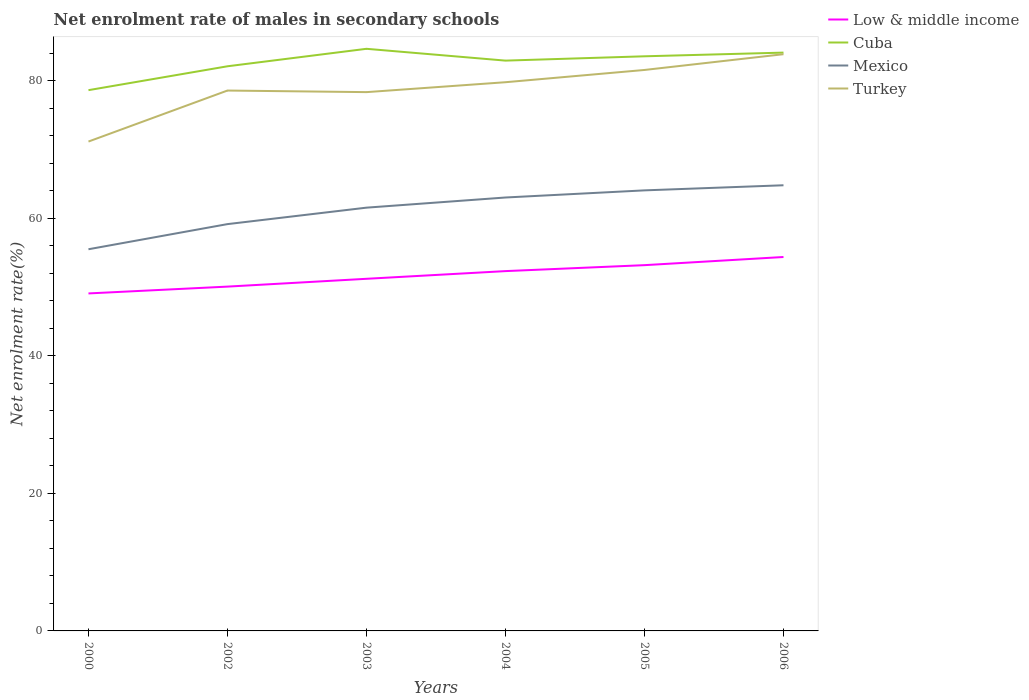How many different coloured lines are there?
Provide a succinct answer. 4. Across all years, what is the maximum net enrolment rate of males in secondary schools in Cuba?
Offer a terse response. 78.62. What is the total net enrolment rate of males in secondary schools in Cuba in the graph?
Keep it short and to the point. -4.29. What is the difference between the highest and the second highest net enrolment rate of males in secondary schools in Low & middle income?
Provide a succinct answer. 5.3. Is the net enrolment rate of males in secondary schools in Turkey strictly greater than the net enrolment rate of males in secondary schools in Mexico over the years?
Offer a very short reply. No. How many lines are there?
Ensure brevity in your answer.  4. What is the difference between two consecutive major ticks on the Y-axis?
Keep it short and to the point. 20. Are the values on the major ticks of Y-axis written in scientific E-notation?
Your response must be concise. No. How are the legend labels stacked?
Your response must be concise. Vertical. What is the title of the graph?
Make the answer very short. Net enrolment rate of males in secondary schools. Does "Timor-Leste" appear as one of the legend labels in the graph?
Make the answer very short. No. What is the label or title of the Y-axis?
Your response must be concise. Net enrolment rate(%). What is the Net enrolment rate(%) of Low & middle income in 2000?
Provide a succinct answer. 49.07. What is the Net enrolment rate(%) in Cuba in 2000?
Provide a short and direct response. 78.62. What is the Net enrolment rate(%) of Mexico in 2000?
Offer a very short reply. 55.49. What is the Net enrolment rate(%) of Turkey in 2000?
Provide a short and direct response. 71.15. What is the Net enrolment rate(%) of Low & middle income in 2002?
Provide a succinct answer. 50.06. What is the Net enrolment rate(%) of Cuba in 2002?
Your answer should be very brief. 82.09. What is the Net enrolment rate(%) in Mexico in 2002?
Provide a succinct answer. 59.15. What is the Net enrolment rate(%) in Turkey in 2002?
Offer a terse response. 78.57. What is the Net enrolment rate(%) in Low & middle income in 2003?
Provide a short and direct response. 51.2. What is the Net enrolment rate(%) in Cuba in 2003?
Give a very brief answer. 84.63. What is the Net enrolment rate(%) of Mexico in 2003?
Ensure brevity in your answer.  61.54. What is the Net enrolment rate(%) in Turkey in 2003?
Provide a short and direct response. 78.34. What is the Net enrolment rate(%) of Low & middle income in 2004?
Ensure brevity in your answer.  52.31. What is the Net enrolment rate(%) of Cuba in 2004?
Make the answer very short. 82.92. What is the Net enrolment rate(%) in Mexico in 2004?
Your response must be concise. 63.02. What is the Net enrolment rate(%) of Turkey in 2004?
Provide a short and direct response. 79.78. What is the Net enrolment rate(%) in Low & middle income in 2005?
Your answer should be very brief. 53.18. What is the Net enrolment rate(%) of Cuba in 2005?
Your answer should be very brief. 83.54. What is the Net enrolment rate(%) of Mexico in 2005?
Offer a very short reply. 64.05. What is the Net enrolment rate(%) of Turkey in 2005?
Ensure brevity in your answer.  81.56. What is the Net enrolment rate(%) in Low & middle income in 2006?
Provide a succinct answer. 54.36. What is the Net enrolment rate(%) of Cuba in 2006?
Offer a terse response. 84.08. What is the Net enrolment rate(%) of Mexico in 2006?
Keep it short and to the point. 64.79. What is the Net enrolment rate(%) of Turkey in 2006?
Provide a short and direct response. 83.85. Across all years, what is the maximum Net enrolment rate(%) of Low & middle income?
Ensure brevity in your answer.  54.36. Across all years, what is the maximum Net enrolment rate(%) in Cuba?
Keep it short and to the point. 84.63. Across all years, what is the maximum Net enrolment rate(%) of Mexico?
Your answer should be compact. 64.79. Across all years, what is the maximum Net enrolment rate(%) of Turkey?
Give a very brief answer. 83.85. Across all years, what is the minimum Net enrolment rate(%) in Low & middle income?
Offer a very short reply. 49.07. Across all years, what is the minimum Net enrolment rate(%) in Cuba?
Make the answer very short. 78.62. Across all years, what is the minimum Net enrolment rate(%) of Mexico?
Offer a very short reply. 55.49. Across all years, what is the minimum Net enrolment rate(%) in Turkey?
Give a very brief answer. 71.15. What is the total Net enrolment rate(%) of Low & middle income in the graph?
Give a very brief answer. 310.18. What is the total Net enrolment rate(%) in Cuba in the graph?
Give a very brief answer. 495.9. What is the total Net enrolment rate(%) of Mexico in the graph?
Your answer should be compact. 368.04. What is the total Net enrolment rate(%) in Turkey in the graph?
Provide a succinct answer. 473.24. What is the difference between the Net enrolment rate(%) in Low & middle income in 2000 and that in 2002?
Provide a succinct answer. -0.99. What is the difference between the Net enrolment rate(%) of Cuba in 2000 and that in 2002?
Ensure brevity in your answer.  -3.47. What is the difference between the Net enrolment rate(%) of Mexico in 2000 and that in 2002?
Provide a short and direct response. -3.65. What is the difference between the Net enrolment rate(%) in Turkey in 2000 and that in 2002?
Provide a short and direct response. -7.42. What is the difference between the Net enrolment rate(%) in Low & middle income in 2000 and that in 2003?
Your answer should be compact. -2.13. What is the difference between the Net enrolment rate(%) in Cuba in 2000 and that in 2003?
Keep it short and to the point. -6.01. What is the difference between the Net enrolment rate(%) of Mexico in 2000 and that in 2003?
Offer a very short reply. -6.05. What is the difference between the Net enrolment rate(%) of Turkey in 2000 and that in 2003?
Keep it short and to the point. -7.19. What is the difference between the Net enrolment rate(%) in Low & middle income in 2000 and that in 2004?
Provide a short and direct response. -3.25. What is the difference between the Net enrolment rate(%) of Cuba in 2000 and that in 2004?
Offer a terse response. -4.29. What is the difference between the Net enrolment rate(%) of Mexico in 2000 and that in 2004?
Your response must be concise. -7.52. What is the difference between the Net enrolment rate(%) in Turkey in 2000 and that in 2004?
Offer a very short reply. -8.63. What is the difference between the Net enrolment rate(%) in Low & middle income in 2000 and that in 2005?
Give a very brief answer. -4.11. What is the difference between the Net enrolment rate(%) in Cuba in 2000 and that in 2005?
Make the answer very short. -4.92. What is the difference between the Net enrolment rate(%) in Mexico in 2000 and that in 2005?
Provide a short and direct response. -8.56. What is the difference between the Net enrolment rate(%) in Turkey in 2000 and that in 2005?
Your answer should be very brief. -10.41. What is the difference between the Net enrolment rate(%) in Low & middle income in 2000 and that in 2006?
Give a very brief answer. -5.3. What is the difference between the Net enrolment rate(%) in Cuba in 2000 and that in 2006?
Offer a terse response. -5.46. What is the difference between the Net enrolment rate(%) of Mexico in 2000 and that in 2006?
Keep it short and to the point. -9.3. What is the difference between the Net enrolment rate(%) of Turkey in 2000 and that in 2006?
Give a very brief answer. -12.7. What is the difference between the Net enrolment rate(%) in Low & middle income in 2002 and that in 2003?
Offer a terse response. -1.14. What is the difference between the Net enrolment rate(%) in Cuba in 2002 and that in 2003?
Offer a very short reply. -2.54. What is the difference between the Net enrolment rate(%) of Mexico in 2002 and that in 2003?
Your answer should be very brief. -2.39. What is the difference between the Net enrolment rate(%) of Turkey in 2002 and that in 2003?
Offer a very short reply. 0.23. What is the difference between the Net enrolment rate(%) of Low & middle income in 2002 and that in 2004?
Make the answer very short. -2.25. What is the difference between the Net enrolment rate(%) of Cuba in 2002 and that in 2004?
Your answer should be very brief. -0.82. What is the difference between the Net enrolment rate(%) in Mexico in 2002 and that in 2004?
Your response must be concise. -3.87. What is the difference between the Net enrolment rate(%) of Turkey in 2002 and that in 2004?
Make the answer very short. -1.21. What is the difference between the Net enrolment rate(%) in Low & middle income in 2002 and that in 2005?
Provide a short and direct response. -3.12. What is the difference between the Net enrolment rate(%) of Cuba in 2002 and that in 2005?
Provide a short and direct response. -1.45. What is the difference between the Net enrolment rate(%) in Mexico in 2002 and that in 2005?
Ensure brevity in your answer.  -4.91. What is the difference between the Net enrolment rate(%) in Turkey in 2002 and that in 2005?
Your response must be concise. -2.99. What is the difference between the Net enrolment rate(%) of Low & middle income in 2002 and that in 2006?
Your response must be concise. -4.3. What is the difference between the Net enrolment rate(%) of Cuba in 2002 and that in 2006?
Your answer should be compact. -1.99. What is the difference between the Net enrolment rate(%) in Mexico in 2002 and that in 2006?
Offer a very short reply. -5.65. What is the difference between the Net enrolment rate(%) in Turkey in 2002 and that in 2006?
Your response must be concise. -5.28. What is the difference between the Net enrolment rate(%) of Low & middle income in 2003 and that in 2004?
Your answer should be compact. -1.12. What is the difference between the Net enrolment rate(%) of Cuba in 2003 and that in 2004?
Your answer should be compact. 1.72. What is the difference between the Net enrolment rate(%) in Mexico in 2003 and that in 2004?
Give a very brief answer. -1.48. What is the difference between the Net enrolment rate(%) of Turkey in 2003 and that in 2004?
Your response must be concise. -1.44. What is the difference between the Net enrolment rate(%) in Low & middle income in 2003 and that in 2005?
Keep it short and to the point. -1.98. What is the difference between the Net enrolment rate(%) of Cuba in 2003 and that in 2005?
Offer a terse response. 1.09. What is the difference between the Net enrolment rate(%) of Mexico in 2003 and that in 2005?
Provide a succinct answer. -2.51. What is the difference between the Net enrolment rate(%) in Turkey in 2003 and that in 2005?
Offer a very short reply. -3.22. What is the difference between the Net enrolment rate(%) in Low & middle income in 2003 and that in 2006?
Offer a very short reply. -3.17. What is the difference between the Net enrolment rate(%) of Cuba in 2003 and that in 2006?
Your response must be concise. 0.55. What is the difference between the Net enrolment rate(%) of Mexico in 2003 and that in 2006?
Offer a terse response. -3.25. What is the difference between the Net enrolment rate(%) of Turkey in 2003 and that in 2006?
Provide a short and direct response. -5.52. What is the difference between the Net enrolment rate(%) of Low & middle income in 2004 and that in 2005?
Your answer should be compact. -0.87. What is the difference between the Net enrolment rate(%) of Cuba in 2004 and that in 2005?
Your answer should be compact. -0.63. What is the difference between the Net enrolment rate(%) in Mexico in 2004 and that in 2005?
Give a very brief answer. -1.04. What is the difference between the Net enrolment rate(%) in Turkey in 2004 and that in 2005?
Your answer should be compact. -1.78. What is the difference between the Net enrolment rate(%) in Low & middle income in 2004 and that in 2006?
Make the answer very short. -2.05. What is the difference between the Net enrolment rate(%) in Cuba in 2004 and that in 2006?
Offer a terse response. -1.16. What is the difference between the Net enrolment rate(%) of Mexico in 2004 and that in 2006?
Your response must be concise. -1.78. What is the difference between the Net enrolment rate(%) in Turkey in 2004 and that in 2006?
Make the answer very short. -4.07. What is the difference between the Net enrolment rate(%) in Low & middle income in 2005 and that in 2006?
Provide a short and direct response. -1.19. What is the difference between the Net enrolment rate(%) in Cuba in 2005 and that in 2006?
Your response must be concise. -0.54. What is the difference between the Net enrolment rate(%) of Mexico in 2005 and that in 2006?
Give a very brief answer. -0.74. What is the difference between the Net enrolment rate(%) of Turkey in 2005 and that in 2006?
Your answer should be compact. -2.29. What is the difference between the Net enrolment rate(%) in Low & middle income in 2000 and the Net enrolment rate(%) in Cuba in 2002?
Keep it short and to the point. -33.03. What is the difference between the Net enrolment rate(%) in Low & middle income in 2000 and the Net enrolment rate(%) in Mexico in 2002?
Ensure brevity in your answer.  -10.08. What is the difference between the Net enrolment rate(%) of Low & middle income in 2000 and the Net enrolment rate(%) of Turkey in 2002?
Your answer should be very brief. -29.5. What is the difference between the Net enrolment rate(%) of Cuba in 2000 and the Net enrolment rate(%) of Mexico in 2002?
Offer a terse response. 19.48. What is the difference between the Net enrolment rate(%) of Cuba in 2000 and the Net enrolment rate(%) of Turkey in 2002?
Offer a terse response. 0.06. What is the difference between the Net enrolment rate(%) in Mexico in 2000 and the Net enrolment rate(%) in Turkey in 2002?
Your answer should be very brief. -23.07. What is the difference between the Net enrolment rate(%) in Low & middle income in 2000 and the Net enrolment rate(%) in Cuba in 2003?
Your response must be concise. -35.57. What is the difference between the Net enrolment rate(%) of Low & middle income in 2000 and the Net enrolment rate(%) of Mexico in 2003?
Your answer should be compact. -12.47. What is the difference between the Net enrolment rate(%) in Low & middle income in 2000 and the Net enrolment rate(%) in Turkey in 2003?
Ensure brevity in your answer.  -29.27. What is the difference between the Net enrolment rate(%) in Cuba in 2000 and the Net enrolment rate(%) in Mexico in 2003?
Provide a short and direct response. 17.08. What is the difference between the Net enrolment rate(%) in Cuba in 2000 and the Net enrolment rate(%) in Turkey in 2003?
Give a very brief answer. 0.29. What is the difference between the Net enrolment rate(%) of Mexico in 2000 and the Net enrolment rate(%) of Turkey in 2003?
Provide a short and direct response. -22.84. What is the difference between the Net enrolment rate(%) of Low & middle income in 2000 and the Net enrolment rate(%) of Cuba in 2004?
Provide a short and direct response. -33.85. What is the difference between the Net enrolment rate(%) of Low & middle income in 2000 and the Net enrolment rate(%) of Mexico in 2004?
Give a very brief answer. -13.95. What is the difference between the Net enrolment rate(%) of Low & middle income in 2000 and the Net enrolment rate(%) of Turkey in 2004?
Keep it short and to the point. -30.71. What is the difference between the Net enrolment rate(%) in Cuba in 2000 and the Net enrolment rate(%) in Mexico in 2004?
Offer a very short reply. 15.61. What is the difference between the Net enrolment rate(%) in Cuba in 2000 and the Net enrolment rate(%) in Turkey in 2004?
Your answer should be very brief. -1.15. What is the difference between the Net enrolment rate(%) of Mexico in 2000 and the Net enrolment rate(%) of Turkey in 2004?
Your answer should be very brief. -24.28. What is the difference between the Net enrolment rate(%) in Low & middle income in 2000 and the Net enrolment rate(%) in Cuba in 2005?
Offer a very short reply. -34.48. What is the difference between the Net enrolment rate(%) in Low & middle income in 2000 and the Net enrolment rate(%) in Mexico in 2005?
Give a very brief answer. -14.98. What is the difference between the Net enrolment rate(%) of Low & middle income in 2000 and the Net enrolment rate(%) of Turkey in 2005?
Your answer should be very brief. -32.49. What is the difference between the Net enrolment rate(%) of Cuba in 2000 and the Net enrolment rate(%) of Mexico in 2005?
Your answer should be compact. 14.57. What is the difference between the Net enrolment rate(%) of Cuba in 2000 and the Net enrolment rate(%) of Turkey in 2005?
Provide a short and direct response. -2.94. What is the difference between the Net enrolment rate(%) in Mexico in 2000 and the Net enrolment rate(%) in Turkey in 2005?
Provide a succinct answer. -26.07. What is the difference between the Net enrolment rate(%) of Low & middle income in 2000 and the Net enrolment rate(%) of Cuba in 2006?
Provide a succinct answer. -35.01. What is the difference between the Net enrolment rate(%) of Low & middle income in 2000 and the Net enrolment rate(%) of Mexico in 2006?
Your answer should be very brief. -15.73. What is the difference between the Net enrolment rate(%) in Low & middle income in 2000 and the Net enrolment rate(%) in Turkey in 2006?
Ensure brevity in your answer.  -34.78. What is the difference between the Net enrolment rate(%) in Cuba in 2000 and the Net enrolment rate(%) in Mexico in 2006?
Offer a terse response. 13.83. What is the difference between the Net enrolment rate(%) in Cuba in 2000 and the Net enrolment rate(%) in Turkey in 2006?
Offer a very short reply. -5.23. What is the difference between the Net enrolment rate(%) of Mexico in 2000 and the Net enrolment rate(%) of Turkey in 2006?
Make the answer very short. -28.36. What is the difference between the Net enrolment rate(%) in Low & middle income in 2002 and the Net enrolment rate(%) in Cuba in 2003?
Give a very brief answer. -34.58. What is the difference between the Net enrolment rate(%) in Low & middle income in 2002 and the Net enrolment rate(%) in Mexico in 2003?
Ensure brevity in your answer.  -11.48. What is the difference between the Net enrolment rate(%) of Low & middle income in 2002 and the Net enrolment rate(%) of Turkey in 2003?
Provide a short and direct response. -28.28. What is the difference between the Net enrolment rate(%) of Cuba in 2002 and the Net enrolment rate(%) of Mexico in 2003?
Offer a very short reply. 20.56. What is the difference between the Net enrolment rate(%) in Cuba in 2002 and the Net enrolment rate(%) in Turkey in 2003?
Your answer should be compact. 3.76. What is the difference between the Net enrolment rate(%) in Mexico in 2002 and the Net enrolment rate(%) in Turkey in 2003?
Your answer should be compact. -19.19. What is the difference between the Net enrolment rate(%) of Low & middle income in 2002 and the Net enrolment rate(%) of Cuba in 2004?
Provide a short and direct response. -32.86. What is the difference between the Net enrolment rate(%) of Low & middle income in 2002 and the Net enrolment rate(%) of Mexico in 2004?
Offer a terse response. -12.96. What is the difference between the Net enrolment rate(%) of Low & middle income in 2002 and the Net enrolment rate(%) of Turkey in 2004?
Provide a succinct answer. -29.72. What is the difference between the Net enrolment rate(%) of Cuba in 2002 and the Net enrolment rate(%) of Mexico in 2004?
Ensure brevity in your answer.  19.08. What is the difference between the Net enrolment rate(%) in Cuba in 2002 and the Net enrolment rate(%) in Turkey in 2004?
Your answer should be very brief. 2.32. What is the difference between the Net enrolment rate(%) of Mexico in 2002 and the Net enrolment rate(%) of Turkey in 2004?
Give a very brief answer. -20.63. What is the difference between the Net enrolment rate(%) of Low & middle income in 2002 and the Net enrolment rate(%) of Cuba in 2005?
Provide a short and direct response. -33.48. What is the difference between the Net enrolment rate(%) of Low & middle income in 2002 and the Net enrolment rate(%) of Mexico in 2005?
Keep it short and to the point. -13.99. What is the difference between the Net enrolment rate(%) in Low & middle income in 2002 and the Net enrolment rate(%) in Turkey in 2005?
Your answer should be very brief. -31.5. What is the difference between the Net enrolment rate(%) in Cuba in 2002 and the Net enrolment rate(%) in Mexico in 2005?
Give a very brief answer. 18.04. What is the difference between the Net enrolment rate(%) in Cuba in 2002 and the Net enrolment rate(%) in Turkey in 2005?
Provide a short and direct response. 0.54. What is the difference between the Net enrolment rate(%) in Mexico in 2002 and the Net enrolment rate(%) in Turkey in 2005?
Ensure brevity in your answer.  -22.41. What is the difference between the Net enrolment rate(%) in Low & middle income in 2002 and the Net enrolment rate(%) in Cuba in 2006?
Give a very brief answer. -34.02. What is the difference between the Net enrolment rate(%) in Low & middle income in 2002 and the Net enrolment rate(%) in Mexico in 2006?
Your answer should be very brief. -14.73. What is the difference between the Net enrolment rate(%) of Low & middle income in 2002 and the Net enrolment rate(%) of Turkey in 2006?
Your answer should be very brief. -33.79. What is the difference between the Net enrolment rate(%) in Cuba in 2002 and the Net enrolment rate(%) in Mexico in 2006?
Provide a succinct answer. 17.3. What is the difference between the Net enrolment rate(%) of Cuba in 2002 and the Net enrolment rate(%) of Turkey in 2006?
Give a very brief answer. -1.76. What is the difference between the Net enrolment rate(%) in Mexico in 2002 and the Net enrolment rate(%) in Turkey in 2006?
Give a very brief answer. -24.71. What is the difference between the Net enrolment rate(%) of Low & middle income in 2003 and the Net enrolment rate(%) of Cuba in 2004?
Keep it short and to the point. -31.72. What is the difference between the Net enrolment rate(%) of Low & middle income in 2003 and the Net enrolment rate(%) of Mexico in 2004?
Keep it short and to the point. -11.82. What is the difference between the Net enrolment rate(%) in Low & middle income in 2003 and the Net enrolment rate(%) in Turkey in 2004?
Make the answer very short. -28.58. What is the difference between the Net enrolment rate(%) in Cuba in 2003 and the Net enrolment rate(%) in Mexico in 2004?
Ensure brevity in your answer.  21.62. What is the difference between the Net enrolment rate(%) of Cuba in 2003 and the Net enrolment rate(%) of Turkey in 2004?
Offer a very short reply. 4.86. What is the difference between the Net enrolment rate(%) of Mexico in 2003 and the Net enrolment rate(%) of Turkey in 2004?
Provide a succinct answer. -18.24. What is the difference between the Net enrolment rate(%) in Low & middle income in 2003 and the Net enrolment rate(%) in Cuba in 2005?
Give a very brief answer. -32.35. What is the difference between the Net enrolment rate(%) of Low & middle income in 2003 and the Net enrolment rate(%) of Mexico in 2005?
Keep it short and to the point. -12.86. What is the difference between the Net enrolment rate(%) in Low & middle income in 2003 and the Net enrolment rate(%) in Turkey in 2005?
Give a very brief answer. -30.36. What is the difference between the Net enrolment rate(%) in Cuba in 2003 and the Net enrolment rate(%) in Mexico in 2005?
Ensure brevity in your answer.  20.58. What is the difference between the Net enrolment rate(%) in Cuba in 2003 and the Net enrolment rate(%) in Turkey in 2005?
Provide a succinct answer. 3.08. What is the difference between the Net enrolment rate(%) of Mexico in 2003 and the Net enrolment rate(%) of Turkey in 2005?
Ensure brevity in your answer.  -20.02. What is the difference between the Net enrolment rate(%) of Low & middle income in 2003 and the Net enrolment rate(%) of Cuba in 2006?
Provide a succinct answer. -32.88. What is the difference between the Net enrolment rate(%) in Low & middle income in 2003 and the Net enrolment rate(%) in Mexico in 2006?
Offer a very short reply. -13.6. What is the difference between the Net enrolment rate(%) in Low & middle income in 2003 and the Net enrolment rate(%) in Turkey in 2006?
Offer a terse response. -32.65. What is the difference between the Net enrolment rate(%) of Cuba in 2003 and the Net enrolment rate(%) of Mexico in 2006?
Ensure brevity in your answer.  19.84. What is the difference between the Net enrolment rate(%) of Cuba in 2003 and the Net enrolment rate(%) of Turkey in 2006?
Your answer should be very brief. 0.78. What is the difference between the Net enrolment rate(%) of Mexico in 2003 and the Net enrolment rate(%) of Turkey in 2006?
Your response must be concise. -22.31. What is the difference between the Net enrolment rate(%) of Low & middle income in 2004 and the Net enrolment rate(%) of Cuba in 2005?
Your answer should be very brief. -31.23. What is the difference between the Net enrolment rate(%) of Low & middle income in 2004 and the Net enrolment rate(%) of Mexico in 2005?
Keep it short and to the point. -11.74. What is the difference between the Net enrolment rate(%) in Low & middle income in 2004 and the Net enrolment rate(%) in Turkey in 2005?
Offer a terse response. -29.25. What is the difference between the Net enrolment rate(%) in Cuba in 2004 and the Net enrolment rate(%) in Mexico in 2005?
Your answer should be very brief. 18.86. What is the difference between the Net enrolment rate(%) in Cuba in 2004 and the Net enrolment rate(%) in Turkey in 2005?
Your answer should be compact. 1.36. What is the difference between the Net enrolment rate(%) of Mexico in 2004 and the Net enrolment rate(%) of Turkey in 2005?
Offer a terse response. -18.54. What is the difference between the Net enrolment rate(%) in Low & middle income in 2004 and the Net enrolment rate(%) in Cuba in 2006?
Provide a succinct answer. -31.77. What is the difference between the Net enrolment rate(%) in Low & middle income in 2004 and the Net enrolment rate(%) in Mexico in 2006?
Offer a terse response. -12.48. What is the difference between the Net enrolment rate(%) of Low & middle income in 2004 and the Net enrolment rate(%) of Turkey in 2006?
Your answer should be very brief. -31.54. What is the difference between the Net enrolment rate(%) of Cuba in 2004 and the Net enrolment rate(%) of Mexico in 2006?
Provide a succinct answer. 18.12. What is the difference between the Net enrolment rate(%) of Cuba in 2004 and the Net enrolment rate(%) of Turkey in 2006?
Provide a succinct answer. -0.93. What is the difference between the Net enrolment rate(%) of Mexico in 2004 and the Net enrolment rate(%) of Turkey in 2006?
Make the answer very short. -20.84. What is the difference between the Net enrolment rate(%) in Low & middle income in 2005 and the Net enrolment rate(%) in Cuba in 2006?
Your answer should be compact. -30.9. What is the difference between the Net enrolment rate(%) of Low & middle income in 2005 and the Net enrolment rate(%) of Mexico in 2006?
Provide a succinct answer. -11.62. What is the difference between the Net enrolment rate(%) in Low & middle income in 2005 and the Net enrolment rate(%) in Turkey in 2006?
Provide a short and direct response. -30.67. What is the difference between the Net enrolment rate(%) in Cuba in 2005 and the Net enrolment rate(%) in Mexico in 2006?
Provide a short and direct response. 18.75. What is the difference between the Net enrolment rate(%) in Cuba in 2005 and the Net enrolment rate(%) in Turkey in 2006?
Keep it short and to the point. -0.31. What is the difference between the Net enrolment rate(%) of Mexico in 2005 and the Net enrolment rate(%) of Turkey in 2006?
Your answer should be very brief. -19.8. What is the average Net enrolment rate(%) of Low & middle income per year?
Your response must be concise. 51.7. What is the average Net enrolment rate(%) of Cuba per year?
Keep it short and to the point. 82.65. What is the average Net enrolment rate(%) of Mexico per year?
Offer a terse response. 61.34. What is the average Net enrolment rate(%) of Turkey per year?
Your answer should be very brief. 78.87. In the year 2000, what is the difference between the Net enrolment rate(%) in Low & middle income and Net enrolment rate(%) in Cuba?
Offer a terse response. -29.55. In the year 2000, what is the difference between the Net enrolment rate(%) in Low & middle income and Net enrolment rate(%) in Mexico?
Give a very brief answer. -6.42. In the year 2000, what is the difference between the Net enrolment rate(%) in Low & middle income and Net enrolment rate(%) in Turkey?
Make the answer very short. -22.08. In the year 2000, what is the difference between the Net enrolment rate(%) of Cuba and Net enrolment rate(%) of Mexico?
Provide a succinct answer. 23.13. In the year 2000, what is the difference between the Net enrolment rate(%) in Cuba and Net enrolment rate(%) in Turkey?
Provide a short and direct response. 7.47. In the year 2000, what is the difference between the Net enrolment rate(%) of Mexico and Net enrolment rate(%) of Turkey?
Ensure brevity in your answer.  -15.66. In the year 2002, what is the difference between the Net enrolment rate(%) of Low & middle income and Net enrolment rate(%) of Cuba?
Keep it short and to the point. -32.03. In the year 2002, what is the difference between the Net enrolment rate(%) of Low & middle income and Net enrolment rate(%) of Mexico?
Ensure brevity in your answer.  -9.09. In the year 2002, what is the difference between the Net enrolment rate(%) of Low & middle income and Net enrolment rate(%) of Turkey?
Your response must be concise. -28.51. In the year 2002, what is the difference between the Net enrolment rate(%) of Cuba and Net enrolment rate(%) of Mexico?
Give a very brief answer. 22.95. In the year 2002, what is the difference between the Net enrolment rate(%) of Cuba and Net enrolment rate(%) of Turkey?
Provide a succinct answer. 3.53. In the year 2002, what is the difference between the Net enrolment rate(%) in Mexico and Net enrolment rate(%) in Turkey?
Your answer should be very brief. -19.42. In the year 2003, what is the difference between the Net enrolment rate(%) in Low & middle income and Net enrolment rate(%) in Cuba?
Offer a terse response. -33.44. In the year 2003, what is the difference between the Net enrolment rate(%) of Low & middle income and Net enrolment rate(%) of Mexico?
Ensure brevity in your answer.  -10.34. In the year 2003, what is the difference between the Net enrolment rate(%) of Low & middle income and Net enrolment rate(%) of Turkey?
Your answer should be very brief. -27.14. In the year 2003, what is the difference between the Net enrolment rate(%) of Cuba and Net enrolment rate(%) of Mexico?
Your answer should be very brief. 23.1. In the year 2003, what is the difference between the Net enrolment rate(%) of Cuba and Net enrolment rate(%) of Turkey?
Make the answer very short. 6.3. In the year 2003, what is the difference between the Net enrolment rate(%) of Mexico and Net enrolment rate(%) of Turkey?
Ensure brevity in your answer.  -16.8. In the year 2004, what is the difference between the Net enrolment rate(%) in Low & middle income and Net enrolment rate(%) in Cuba?
Provide a succinct answer. -30.6. In the year 2004, what is the difference between the Net enrolment rate(%) of Low & middle income and Net enrolment rate(%) of Mexico?
Your answer should be very brief. -10.7. In the year 2004, what is the difference between the Net enrolment rate(%) of Low & middle income and Net enrolment rate(%) of Turkey?
Give a very brief answer. -27.46. In the year 2004, what is the difference between the Net enrolment rate(%) in Cuba and Net enrolment rate(%) in Mexico?
Your response must be concise. 19.9. In the year 2004, what is the difference between the Net enrolment rate(%) in Cuba and Net enrolment rate(%) in Turkey?
Ensure brevity in your answer.  3.14. In the year 2004, what is the difference between the Net enrolment rate(%) of Mexico and Net enrolment rate(%) of Turkey?
Make the answer very short. -16.76. In the year 2005, what is the difference between the Net enrolment rate(%) of Low & middle income and Net enrolment rate(%) of Cuba?
Offer a terse response. -30.37. In the year 2005, what is the difference between the Net enrolment rate(%) in Low & middle income and Net enrolment rate(%) in Mexico?
Give a very brief answer. -10.87. In the year 2005, what is the difference between the Net enrolment rate(%) of Low & middle income and Net enrolment rate(%) of Turkey?
Your answer should be very brief. -28.38. In the year 2005, what is the difference between the Net enrolment rate(%) of Cuba and Net enrolment rate(%) of Mexico?
Ensure brevity in your answer.  19.49. In the year 2005, what is the difference between the Net enrolment rate(%) of Cuba and Net enrolment rate(%) of Turkey?
Provide a succinct answer. 1.99. In the year 2005, what is the difference between the Net enrolment rate(%) of Mexico and Net enrolment rate(%) of Turkey?
Your response must be concise. -17.51. In the year 2006, what is the difference between the Net enrolment rate(%) of Low & middle income and Net enrolment rate(%) of Cuba?
Your answer should be compact. -29.72. In the year 2006, what is the difference between the Net enrolment rate(%) of Low & middle income and Net enrolment rate(%) of Mexico?
Keep it short and to the point. -10.43. In the year 2006, what is the difference between the Net enrolment rate(%) of Low & middle income and Net enrolment rate(%) of Turkey?
Provide a short and direct response. -29.49. In the year 2006, what is the difference between the Net enrolment rate(%) of Cuba and Net enrolment rate(%) of Mexico?
Offer a very short reply. 19.29. In the year 2006, what is the difference between the Net enrolment rate(%) in Cuba and Net enrolment rate(%) in Turkey?
Give a very brief answer. 0.23. In the year 2006, what is the difference between the Net enrolment rate(%) in Mexico and Net enrolment rate(%) in Turkey?
Your answer should be compact. -19.06. What is the ratio of the Net enrolment rate(%) in Low & middle income in 2000 to that in 2002?
Your answer should be compact. 0.98. What is the ratio of the Net enrolment rate(%) of Cuba in 2000 to that in 2002?
Offer a very short reply. 0.96. What is the ratio of the Net enrolment rate(%) of Mexico in 2000 to that in 2002?
Offer a terse response. 0.94. What is the ratio of the Net enrolment rate(%) in Turkey in 2000 to that in 2002?
Provide a short and direct response. 0.91. What is the ratio of the Net enrolment rate(%) of Low & middle income in 2000 to that in 2003?
Offer a very short reply. 0.96. What is the ratio of the Net enrolment rate(%) of Cuba in 2000 to that in 2003?
Keep it short and to the point. 0.93. What is the ratio of the Net enrolment rate(%) in Mexico in 2000 to that in 2003?
Keep it short and to the point. 0.9. What is the ratio of the Net enrolment rate(%) of Turkey in 2000 to that in 2003?
Offer a terse response. 0.91. What is the ratio of the Net enrolment rate(%) of Low & middle income in 2000 to that in 2004?
Provide a short and direct response. 0.94. What is the ratio of the Net enrolment rate(%) in Cuba in 2000 to that in 2004?
Your answer should be compact. 0.95. What is the ratio of the Net enrolment rate(%) of Mexico in 2000 to that in 2004?
Provide a succinct answer. 0.88. What is the ratio of the Net enrolment rate(%) of Turkey in 2000 to that in 2004?
Your answer should be very brief. 0.89. What is the ratio of the Net enrolment rate(%) in Low & middle income in 2000 to that in 2005?
Your response must be concise. 0.92. What is the ratio of the Net enrolment rate(%) of Cuba in 2000 to that in 2005?
Your response must be concise. 0.94. What is the ratio of the Net enrolment rate(%) in Mexico in 2000 to that in 2005?
Your answer should be very brief. 0.87. What is the ratio of the Net enrolment rate(%) in Turkey in 2000 to that in 2005?
Offer a very short reply. 0.87. What is the ratio of the Net enrolment rate(%) in Low & middle income in 2000 to that in 2006?
Keep it short and to the point. 0.9. What is the ratio of the Net enrolment rate(%) of Cuba in 2000 to that in 2006?
Give a very brief answer. 0.94. What is the ratio of the Net enrolment rate(%) in Mexico in 2000 to that in 2006?
Provide a succinct answer. 0.86. What is the ratio of the Net enrolment rate(%) in Turkey in 2000 to that in 2006?
Your answer should be very brief. 0.85. What is the ratio of the Net enrolment rate(%) of Low & middle income in 2002 to that in 2003?
Give a very brief answer. 0.98. What is the ratio of the Net enrolment rate(%) of Cuba in 2002 to that in 2003?
Your response must be concise. 0.97. What is the ratio of the Net enrolment rate(%) in Mexico in 2002 to that in 2003?
Your response must be concise. 0.96. What is the ratio of the Net enrolment rate(%) in Turkey in 2002 to that in 2003?
Offer a terse response. 1. What is the ratio of the Net enrolment rate(%) of Low & middle income in 2002 to that in 2004?
Your answer should be compact. 0.96. What is the ratio of the Net enrolment rate(%) of Mexico in 2002 to that in 2004?
Your response must be concise. 0.94. What is the ratio of the Net enrolment rate(%) in Low & middle income in 2002 to that in 2005?
Provide a short and direct response. 0.94. What is the ratio of the Net enrolment rate(%) in Cuba in 2002 to that in 2005?
Provide a succinct answer. 0.98. What is the ratio of the Net enrolment rate(%) of Mexico in 2002 to that in 2005?
Your answer should be compact. 0.92. What is the ratio of the Net enrolment rate(%) in Turkey in 2002 to that in 2005?
Keep it short and to the point. 0.96. What is the ratio of the Net enrolment rate(%) in Low & middle income in 2002 to that in 2006?
Your response must be concise. 0.92. What is the ratio of the Net enrolment rate(%) of Cuba in 2002 to that in 2006?
Make the answer very short. 0.98. What is the ratio of the Net enrolment rate(%) of Mexico in 2002 to that in 2006?
Give a very brief answer. 0.91. What is the ratio of the Net enrolment rate(%) of Turkey in 2002 to that in 2006?
Give a very brief answer. 0.94. What is the ratio of the Net enrolment rate(%) of Low & middle income in 2003 to that in 2004?
Your response must be concise. 0.98. What is the ratio of the Net enrolment rate(%) in Cuba in 2003 to that in 2004?
Make the answer very short. 1.02. What is the ratio of the Net enrolment rate(%) in Mexico in 2003 to that in 2004?
Provide a succinct answer. 0.98. What is the ratio of the Net enrolment rate(%) in Turkey in 2003 to that in 2004?
Give a very brief answer. 0.98. What is the ratio of the Net enrolment rate(%) in Low & middle income in 2003 to that in 2005?
Offer a very short reply. 0.96. What is the ratio of the Net enrolment rate(%) in Cuba in 2003 to that in 2005?
Provide a succinct answer. 1.01. What is the ratio of the Net enrolment rate(%) of Mexico in 2003 to that in 2005?
Keep it short and to the point. 0.96. What is the ratio of the Net enrolment rate(%) in Turkey in 2003 to that in 2005?
Offer a terse response. 0.96. What is the ratio of the Net enrolment rate(%) in Low & middle income in 2003 to that in 2006?
Provide a short and direct response. 0.94. What is the ratio of the Net enrolment rate(%) of Cuba in 2003 to that in 2006?
Ensure brevity in your answer.  1.01. What is the ratio of the Net enrolment rate(%) of Mexico in 2003 to that in 2006?
Keep it short and to the point. 0.95. What is the ratio of the Net enrolment rate(%) in Turkey in 2003 to that in 2006?
Provide a succinct answer. 0.93. What is the ratio of the Net enrolment rate(%) in Low & middle income in 2004 to that in 2005?
Make the answer very short. 0.98. What is the ratio of the Net enrolment rate(%) of Mexico in 2004 to that in 2005?
Your answer should be compact. 0.98. What is the ratio of the Net enrolment rate(%) of Turkey in 2004 to that in 2005?
Offer a terse response. 0.98. What is the ratio of the Net enrolment rate(%) in Low & middle income in 2004 to that in 2006?
Your response must be concise. 0.96. What is the ratio of the Net enrolment rate(%) in Cuba in 2004 to that in 2006?
Your response must be concise. 0.99. What is the ratio of the Net enrolment rate(%) in Mexico in 2004 to that in 2006?
Provide a succinct answer. 0.97. What is the ratio of the Net enrolment rate(%) in Turkey in 2004 to that in 2006?
Offer a very short reply. 0.95. What is the ratio of the Net enrolment rate(%) of Low & middle income in 2005 to that in 2006?
Keep it short and to the point. 0.98. What is the ratio of the Net enrolment rate(%) of Cuba in 2005 to that in 2006?
Ensure brevity in your answer.  0.99. What is the ratio of the Net enrolment rate(%) of Turkey in 2005 to that in 2006?
Your answer should be very brief. 0.97. What is the difference between the highest and the second highest Net enrolment rate(%) of Low & middle income?
Make the answer very short. 1.19. What is the difference between the highest and the second highest Net enrolment rate(%) in Cuba?
Your answer should be compact. 0.55. What is the difference between the highest and the second highest Net enrolment rate(%) in Mexico?
Ensure brevity in your answer.  0.74. What is the difference between the highest and the second highest Net enrolment rate(%) in Turkey?
Your response must be concise. 2.29. What is the difference between the highest and the lowest Net enrolment rate(%) in Low & middle income?
Offer a very short reply. 5.3. What is the difference between the highest and the lowest Net enrolment rate(%) of Cuba?
Make the answer very short. 6.01. What is the difference between the highest and the lowest Net enrolment rate(%) of Mexico?
Your response must be concise. 9.3. What is the difference between the highest and the lowest Net enrolment rate(%) in Turkey?
Your answer should be very brief. 12.7. 